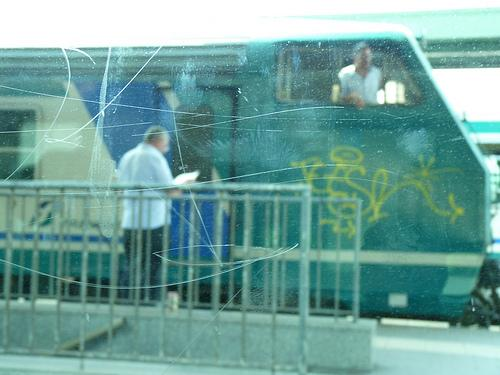Illustrate the main aspects of the photo including the primary individual and location. In the image, a man reads a newspaper while standing next to a light green train embellished with yellow graffiti, with tall metal fences as a backdrop. Concisely depict the key person and their action taking place in the image. An older, glasses-wearing gentleman reads a newspaper by a train adorned with graffiti. Mention the most prominent object and activity in the picture. A man is reading a newspaper near a train with distinguishable graffiti. Briefly outline the primary elements and actions depicted in the image. An older man wearing a white shirt and glasses reads a newspaper while waiting for a light green train with yellow graffiti on its side. Explain what the central individual is doing in the context of the image. An older man, dressed in a white shirt and black pants, is preoccupied with reading a newspaper next to a train covered in graffiti. In a concise manner, describe the primary person and their action in the picture. An elderly man in a white shirt reads a newspaper beside a graffiti-laden train. Describe the image focusing on the most noticeable person and action. A man wearing a white shirt and glasses is engrossed in reading a newspaper beside a graffitied train. Give a brief account of the primary subject and the action happening in the image. A man wearing glasses and a white shirt reads a newspaper alongside a train with conspicuous graffiti. Provide a succinct description of the main subject and their activity within the image. A man, clad in a white shirt, is engrossed in a newspaper near a graffitied train. Furnish a short description of the main object and any noteworthy activity occurring in the photo. A man is absorbed in a newspaper while waiting near a train showcasing prominent graffiti. 